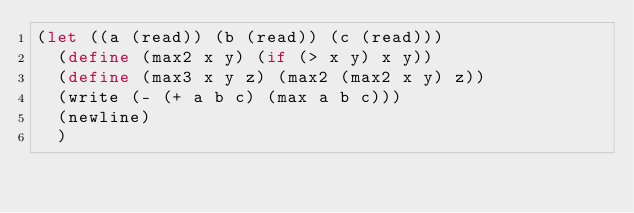<code> <loc_0><loc_0><loc_500><loc_500><_Scheme_>(let ((a (read)) (b (read)) (c (read)))
  (define (max2 x y) (if (> x y) x y))
  (define (max3 x y z) (max2 (max2 x y) z))
  (write (- (+ a b c) (max a b c)))
  (newline)
  )
</code> 